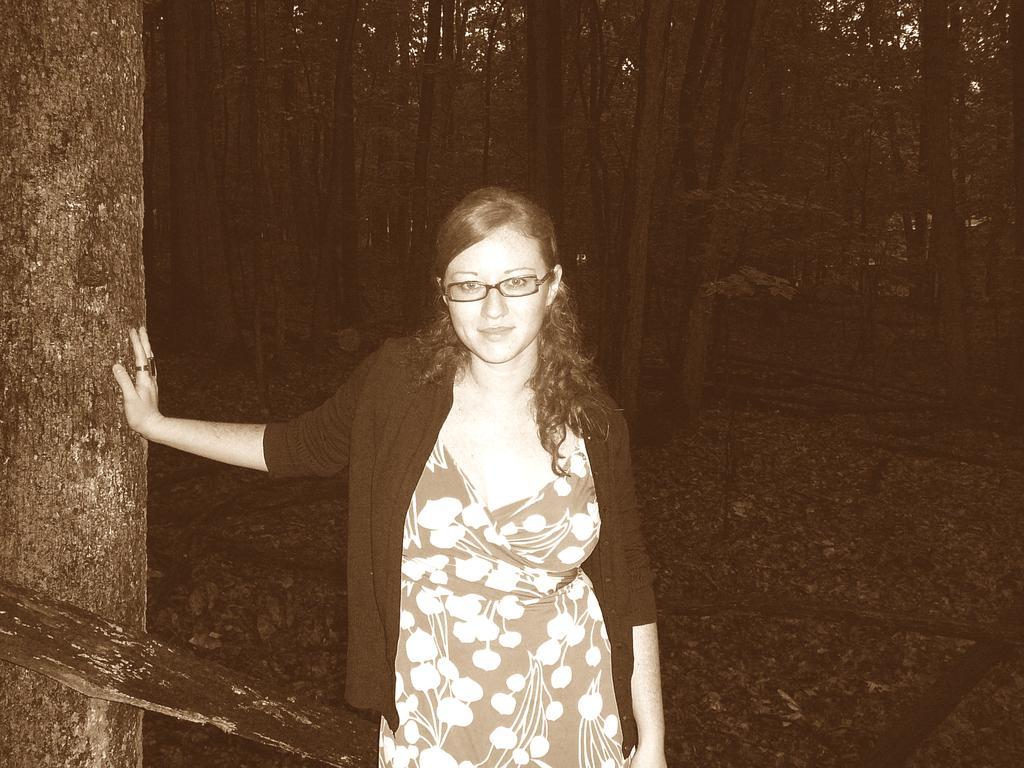How would you summarize this image in a sentence or two? In this image I can see a woman is standing and wearing spectacles. In the background I can see trees. This image is black and white in color. 